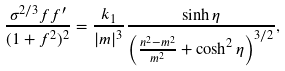<formula> <loc_0><loc_0><loc_500><loc_500>\frac { \sigma ^ { 2 / 3 } f f ^ { \prime } } { ( 1 + f ^ { 2 } ) ^ { 2 } } = \frac { k _ { 1 } } { | m | ^ { 3 } } \frac { \sinh \eta } { \left ( \frac { n ^ { 2 } - m ^ { 2 } } { m ^ { 2 } } + \cosh ^ { 2 } \eta \right ) ^ { 3 / 2 } } ,</formula> 